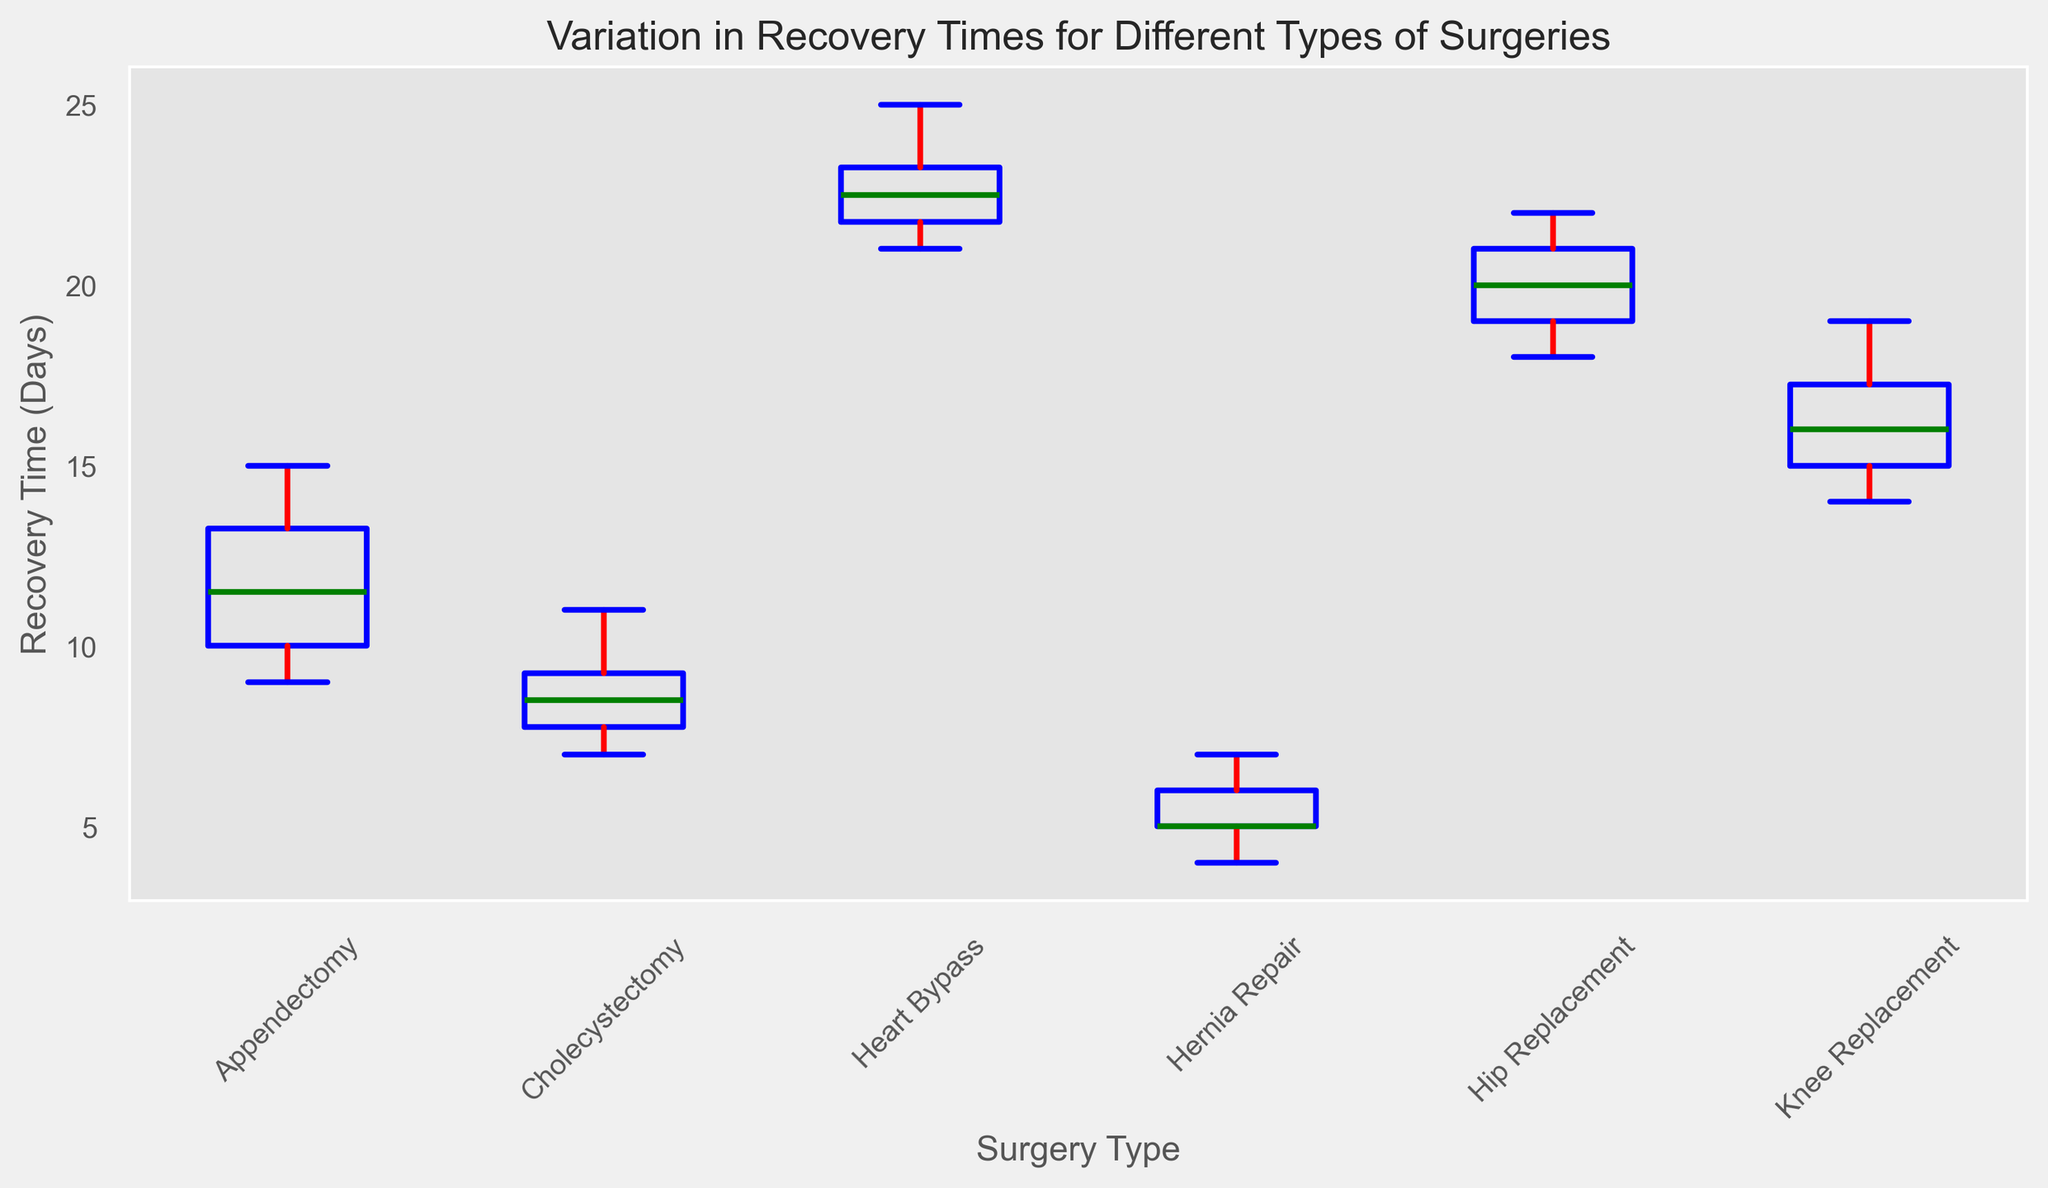What type of surgery has the highest median recovery time? The median can be identified by looking at the green line inside each box plot. The Heart Bypass has the highest median recovery time as its green line is positioned higher on the vertical axis compared to others.
Answer: Heart Bypass Compare the range (the difference between the maximum and minimum) of recovery times between Appendectomy and Hernia Repair surgeries. The range can be identified by looking at the whiskers (vertical lines) extending from the box. For Appendectomy, the range is from 9 to 15 (difference is 6 days), and for Hernia Repair, it is from 4 to 7 (difference is 3 days). Appendectomy has a wider range.
Answer: Appendectomy: 6, Hernia Repair: 3 Which surgery type shows the least variation in recovery times? The least variation can be indicated by the smallest interquartile range (the box's height). Hernia Repair has the smallest height of the box, indicating the least variation.
Answer: Hernia Repair Is the median recovery time for Knee Replacement longer than for Cholecystectomy? By looking at the green lines inside the boxes, the median for Knee Replacement is higher than that for Cholecystectomy.
Answer: Yes Which surgery types have outliers in their recovery time data, and what are these outliers? Outliers are marked by orange dots outside the whiskers. Appendectomy has one outlier at 15, and Heart Bypass has one outlier at 25.
Answer: Appendectomy, Heart Bypass Between Hip Replacement and Knee Replacement, which has a higher upper quartile recovery time? The upper quartile (top of the box) is higher for Hip Replacement compared to Knee Replacement.
Answer: Hip Replacement Are the recovery times more spread out for surgeries with higher median recovery times? Observe the width of the box plots and the position of the green median lines. Heart Bypass, which has the highest median, also shows a wider spread in the box plot.
Answer: Yes Which surgery type has the shortest lower whisker, and what does this imply about its recovery time distribution? The shortest lower whisker is in Hernia Repair, indicating it has a relatively tight lower distribution of recovery times.
Answer: Hernia Repair Compare the interquartile ranges (IQR) of Heart Bypass and Knee Replacement surgeries. The IQR is the height of the box from the lower quartile to the upper quartile. Heart Bypass shows a taller box (greater IQR) compared to Knee Replacement.
Answer: Heart Bypass What is the median recovery time for Cholecystectomy? The green line inside Cholecystectomy's box plot represents the median recovery time, which is approximately 9 days.
Answer: 9 days 